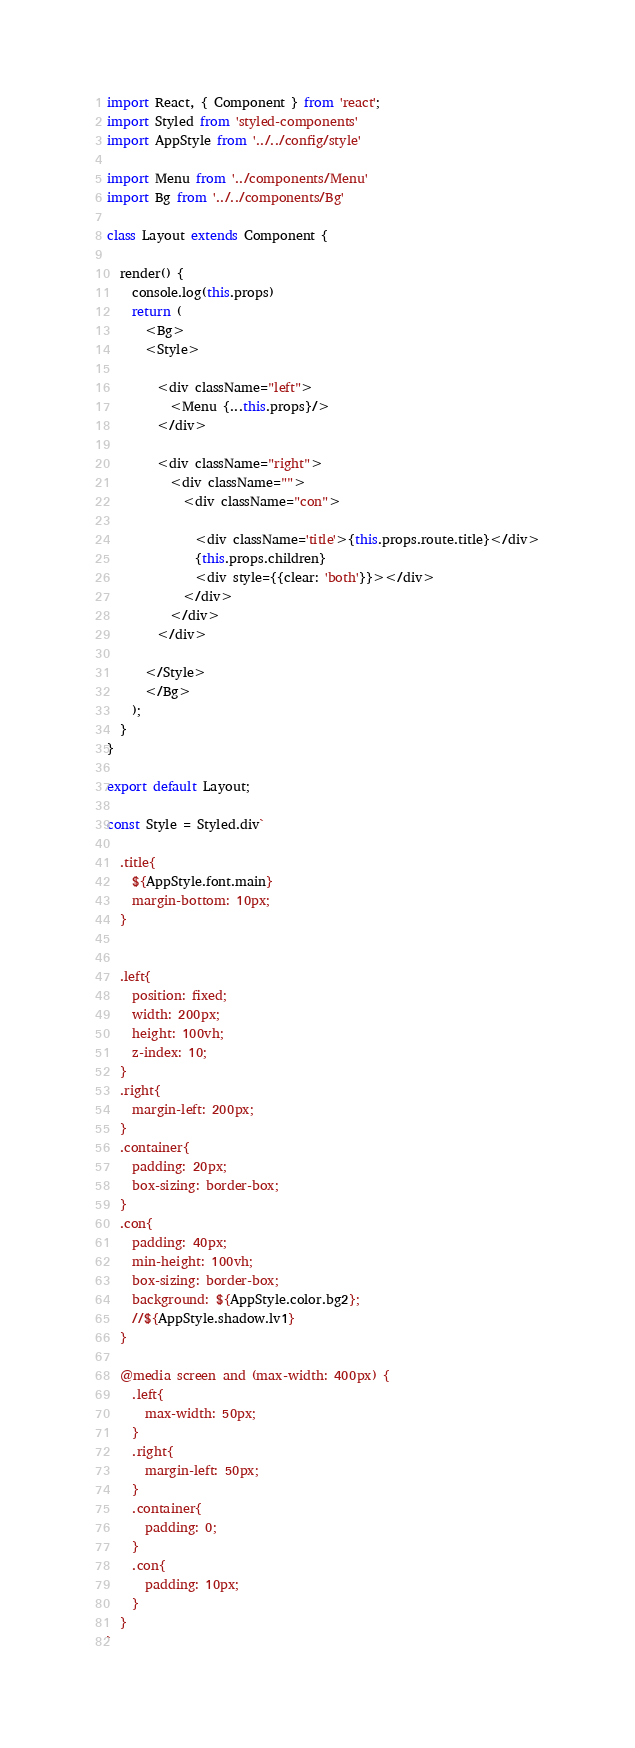Convert code to text. <code><loc_0><loc_0><loc_500><loc_500><_JavaScript_>import React, { Component } from 'react';
import Styled from 'styled-components'
import AppStyle from '../../config/style'

import Menu from '../components/Menu'
import Bg from '../../components/Bg'

class Layout extends Component {

  render() {
    console.log(this.props)
    return (
      <Bg>
      <Style>

        <div className="left">
          <Menu {...this.props}/>
        </div>

        <div className="right">
          <div className="">
            <div className="con">
            
              <div className='title'>{this.props.route.title}</div>
              {this.props.children}
              <div style={{clear: 'both'}}></div>
            </div>
          </div>
        </div>

      </Style>
      </Bg>
    );
  }
}

export default Layout;

const Style = Styled.div`

  .title{
    ${AppStyle.font.main}
    margin-bottom: 10px;
  }


  .left{
    position: fixed;
    width: 200px;
    height: 100vh;
    z-index: 10;
  }
  .right{
    margin-left: 200px;
  }
  .container{
    padding: 20px;
    box-sizing: border-box;
  }
  .con{
    padding: 40px;
    min-height: 100vh;
    box-sizing: border-box;
    background: ${AppStyle.color.bg2};
    //${AppStyle.shadow.lv1}
  }

  @media screen and (max-width: 400px) {
    .left{
      max-width: 50px;
    }
    .right{
      margin-left: 50px;
    }
    .container{
      padding: 0;
    }
    .con{
      padding: 10px;
    }
  }
`</code> 